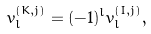Convert formula to latex. <formula><loc_0><loc_0><loc_500><loc_500>v _ { l } ^ { ( K , j ) } = ( - 1 ) ^ { l } v _ { l } ^ { ( I , j ) } ,</formula> 